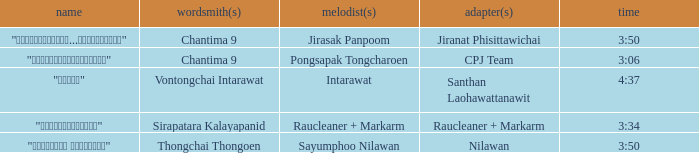Can you parse all the data within this table? {'header': ['name', 'wordsmith(s)', 'melodist(s)', 'adapter(s)', 'time'], 'rows': [['"เรายังรักกัน...ไม่ใช่เหรอ"', 'Chantima 9', 'Jirasak Panpoom', 'Jiranat Phisittawichai', '3:50'], ['"นางฟ้าตาชั้นเดียว"', 'Chantima 9', 'Pongsapak Tongcharoen', 'CPJ Team', '3:06'], ['"ขอโทษ"', 'Vontongchai Intarawat', 'Intarawat', 'Santhan Laohawattanawit', '4:37'], ['"แค่อยากให้รู้"', 'Sirapatara Kalayapanid', 'Raucleaner + Markarm', 'Raucleaner + Markarm', '3:34'], ['"เลือกลืม เลือกจำ"', 'Thongchai Thongoen', 'Sayumphoo Nilawan', 'Nilawan', '3:50']]} Who was the arranger for the song that had a lyricist of Sirapatara Kalayapanid? Raucleaner + Markarm. 